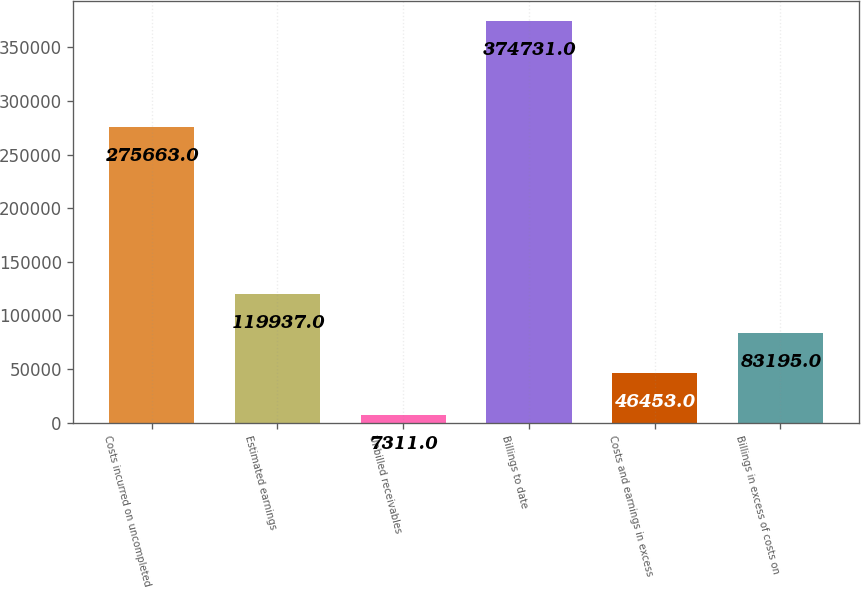Convert chart to OTSL. <chart><loc_0><loc_0><loc_500><loc_500><bar_chart><fcel>Costs incurred on uncompleted<fcel>Estimated earnings<fcel>Unbilled receivables<fcel>Billings to date<fcel>Costs and earnings in excess<fcel>Billings in excess of costs on<nl><fcel>275663<fcel>119937<fcel>7311<fcel>374731<fcel>46453<fcel>83195<nl></chart> 